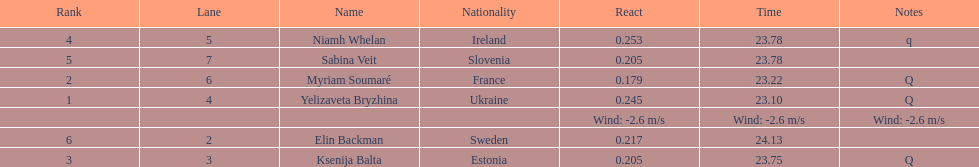Whose time is more than. 24.00? Elin Backman. 